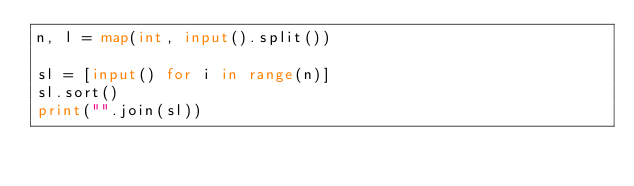Convert code to text. <code><loc_0><loc_0><loc_500><loc_500><_Python_>n, l = map(int, input().split())

sl = [input() for i in range(n)]
sl.sort()
print("".join(sl))</code> 